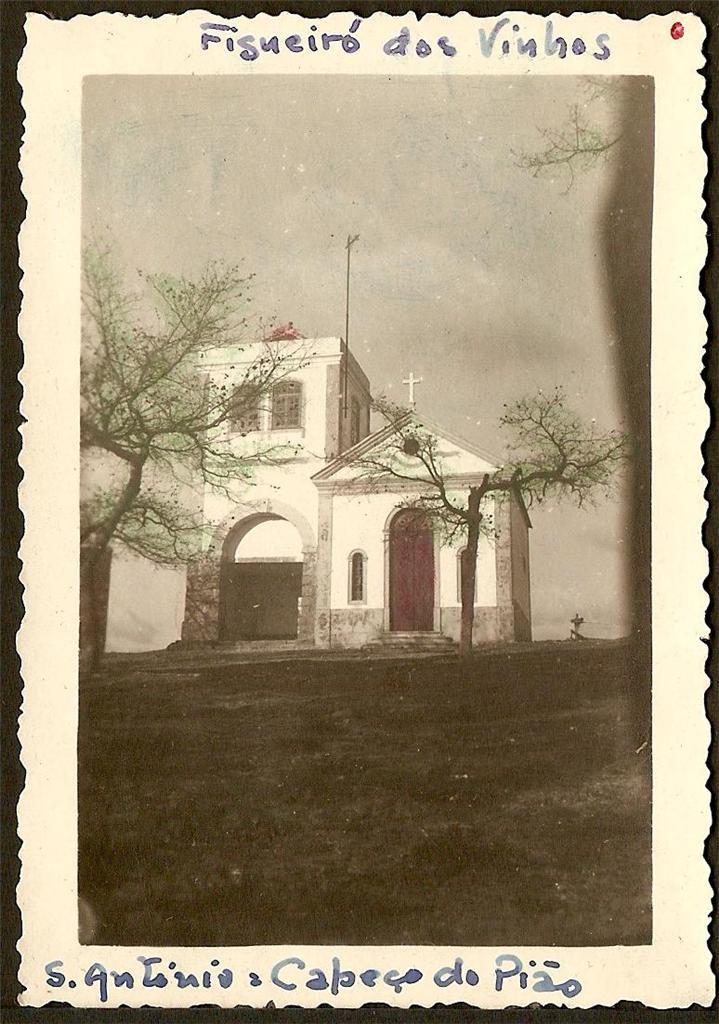What is the name of this building?
Offer a very short reply. Figueiro dos vinhos. Who is the artist name?
Your answer should be very brief. Figueiro dos vinhos. 